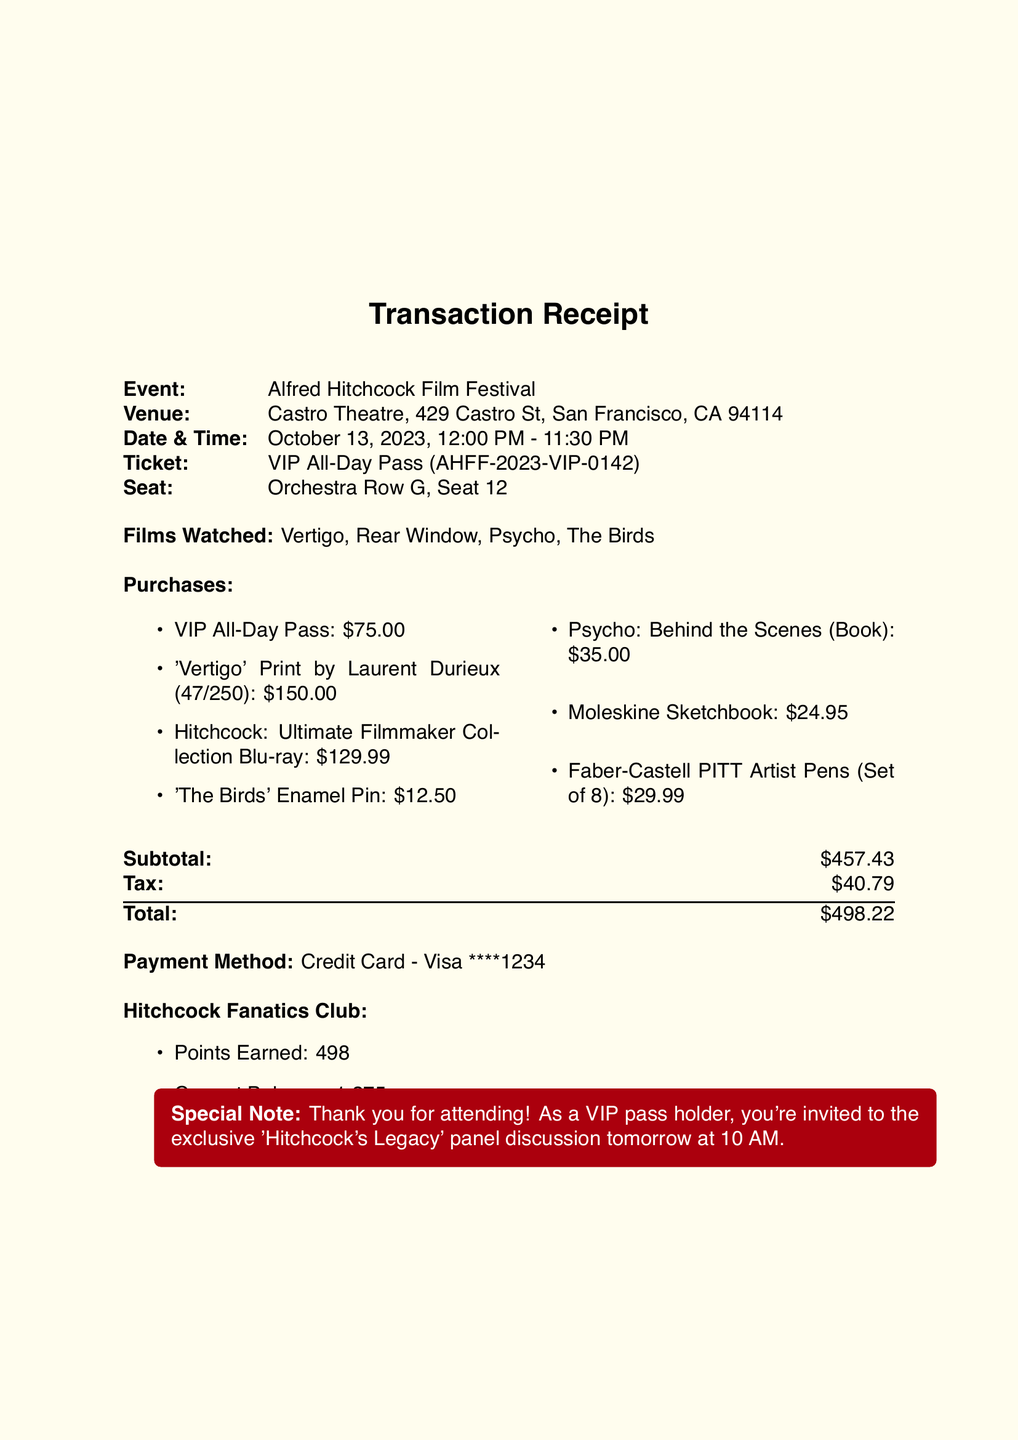What is the name of the event? The name of the event is clearly stated in the document.
Answer: Alfred Hitchcock Film Festival What type of ticket was purchased? The ticket type is specified in the document under the ticket section.
Answer: VIP All-Day Pass What is the price of the limited edition print? The document lists the price of the limited edition print as part of the merchandise purchases.
Answer: 150.00 How many points were earned in the loyalty program? The points earned are explicitly mentioned in the loyalty program section of the document.
Answer: 498 What is the total amount spent? The total payment is clearly noted towards the end of the document.
Answer: 498.22 What is the edition number of the 'Vertigo' print? The edition number for the 'Vertigo' print is provided with the item details in the merchandise section.
Answer: 47/250 What films were watched at the festival? The films watched are listed immediately after the ticket information in the document.
Answer: Vertigo, Rear Window, Psycho, The Birds What is the payment method used? The payment method is detailed in the payment section of the document.
Answer: Credit Card - Visa ****1234 